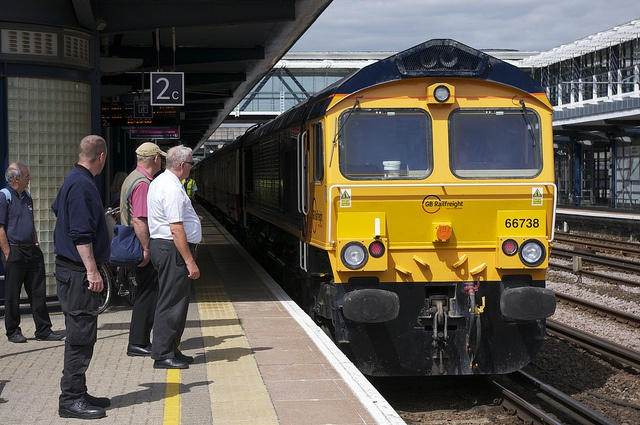Describe the objects in this image and their specific colors. I can see train in black, orange, gray, and olive tones, people in black, gray, and darkgray tones, people in black, lavender, gray, and darkgray tones, people in black, gray, and darkgray tones, and people in black, gray, darkgray, and brown tones in this image. 